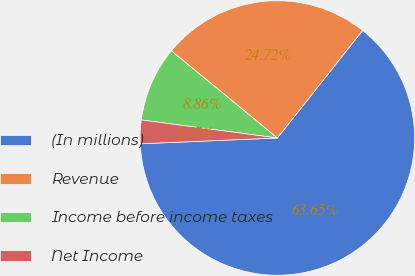<chart> <loc_0><loc_0><loc_500><loc_500><pie_chart><fcel>(In millions)<fcel>Revenue<fcel>Income before income taxes<fcel>Net Income<nl><fcel>63.66%<fcel>24.72%<fcel>8.86%<fcel>2.77%<nl></chart> 